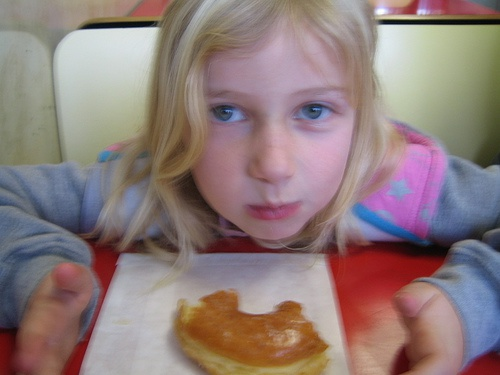Describe the objects in this image and their specific colors. I can see people in gray and darkgray tones, chair in gray, darkgray, and lightgray tones, donut in gray, brown, tan, and darkgray tones, and dining table in gray, brown, maroon, and black tones in this image. 